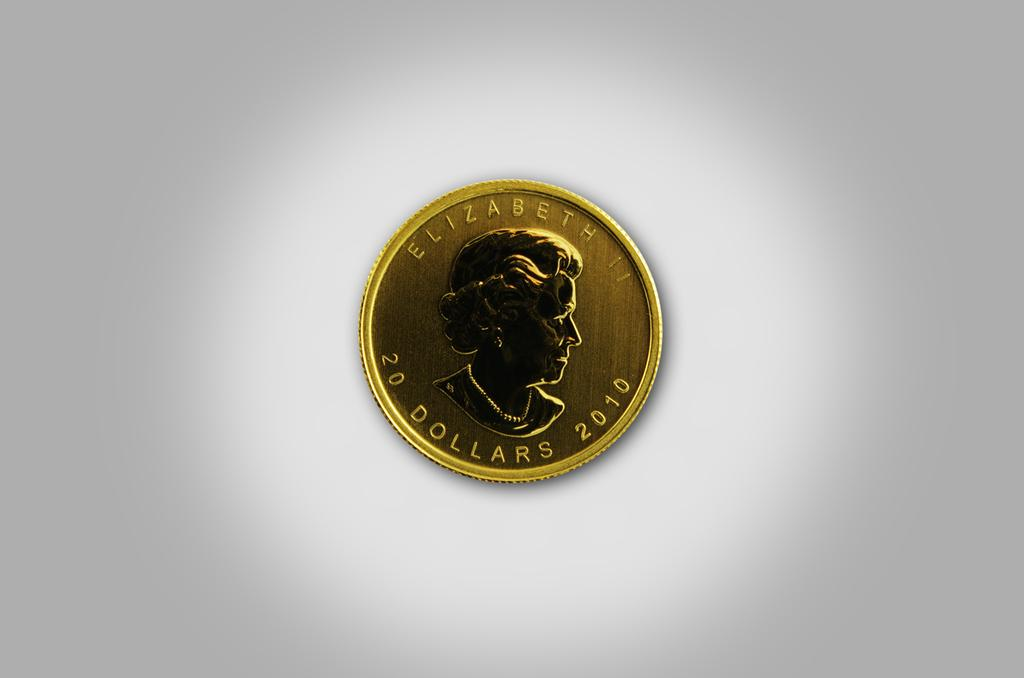<image>
Relay a brief, clear account of the picture shown. A golden coin worth 20 dollars has the year 2010 on it. 